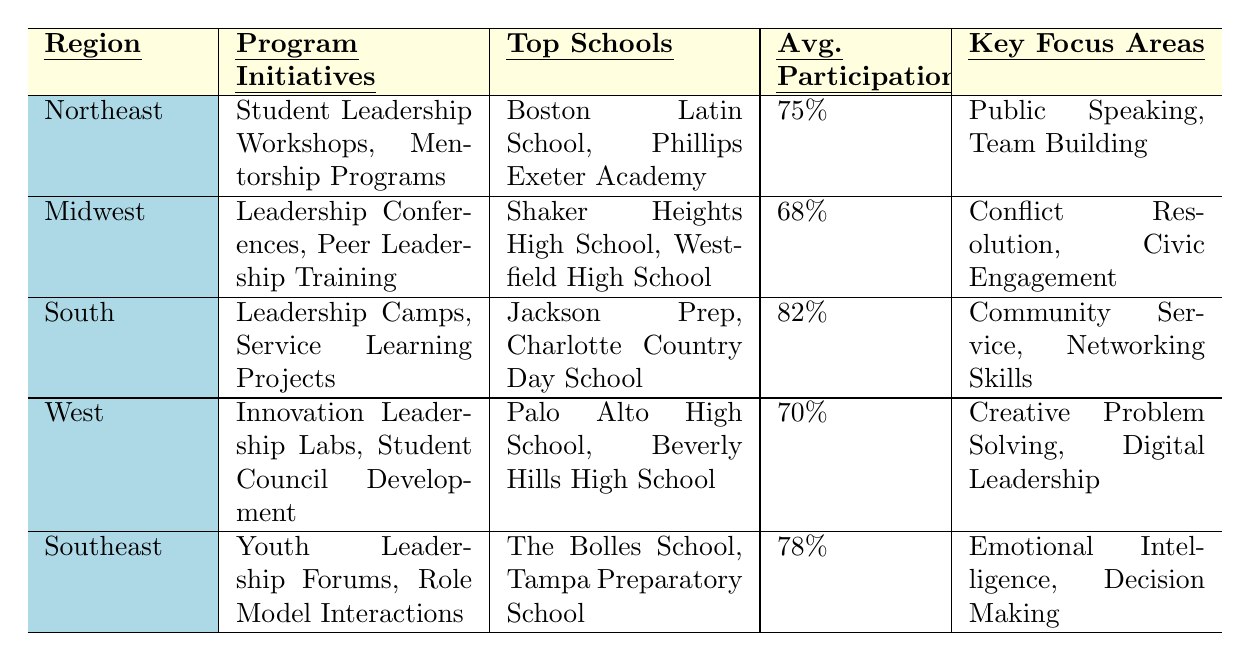What is the average participation rate in the South region? The average participation rate for the South region, as listed in the table, is 82%.
Answer: 82% Which program initiatives are present in the Northeast region? The program initiatives for the Northeast region include Student Leadership Workshops and Mentorship Programs, as specified in the table.
Answer: Student Leadership Workshops, Mentorship Programs What are the top two schools in the Midwest region? The table lists Shaker Heights High School and Westfield High School as the top schools in the Midwest region.
Answer: Shaker Heights High School, Westfield High School Is the average participation rate in the West region higher than in the Northeast region? The average participation rate in the West region is 70%, while in the Northeast it is 75%. Since 70% is less than 75%, the statement is false.
Answer: No Which region has the highest average participation rate? Reviewing the average participation rates across all regions, the South region at 82% has the highest rate compared to others (Northeast 75%, Midwest 68%, West 70%, Southeast 78%).
Answer: South What are the key focus areas for leadership development in the Southeast region? The key focus areas for the Southeast region, as stated in the table, are Emotional Intelligence and Decision Making.
Answer: Emotional Intelligence, Decision Making Compare the average participation rates of the Midwest and Southeast regions. The average participation rate in the Midwest is 68%, while in the Southeast it is 78%. The Southeast region's rate is higher by 10%.
Answer: Southeast is higher by 10% Are there any program initiatives that focus on digital leadership? Yes, the West region includes program initiatives that focus on Digital Leadership, as indicated in the key focus areas of the table.
Answer: Yes Which region has the lowest average participation rate? The Midwest region has the lowest average participation rate of 68%, according to the data in the table.
Answer: Midwest What is the total number of key focus areas across all regions listed in the table? There are five regions each with two key focus areas, totaling 10 key focus areas across the table.
Answer: 10 